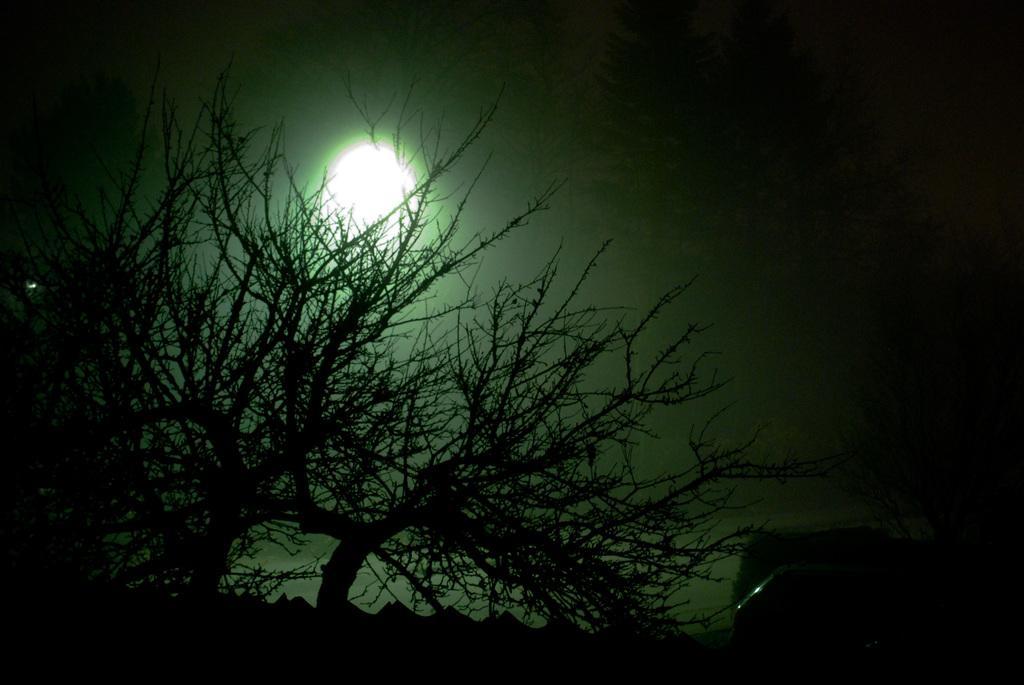Can you describe this image briefly? This picture is clicked outside. In the foreground we can see there are some objects. In the background we can see the trees and the moon in the sky. 